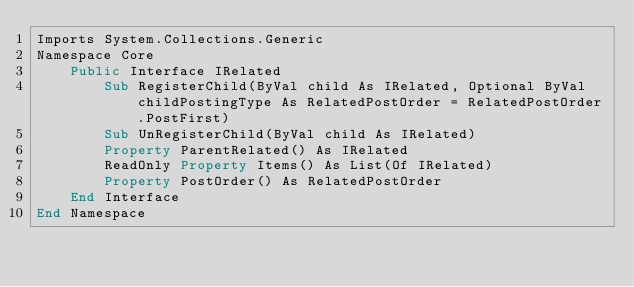Convert code to text. <code><loc_0><loc_0><loc_500><loc_500><_VisualBasic_>Imports System.Collections.Generic
Namespace Core
    Public Interface IRelated
        Sub RegisterChild(ByVal child As IRelated, Optional ByVal childPostingType As RelatedPostOrder = RelatedPostOrder.PostFirst)
        Sub UnRegisterChild(ByVal child As IRelated)
        Property ParentRelated() As IRelated
        ReadOnly Property Items() As List(Of IRelated)
        Property PostOrder() As RelatedPostOrder
    End Interface
End Namespace

</code> 